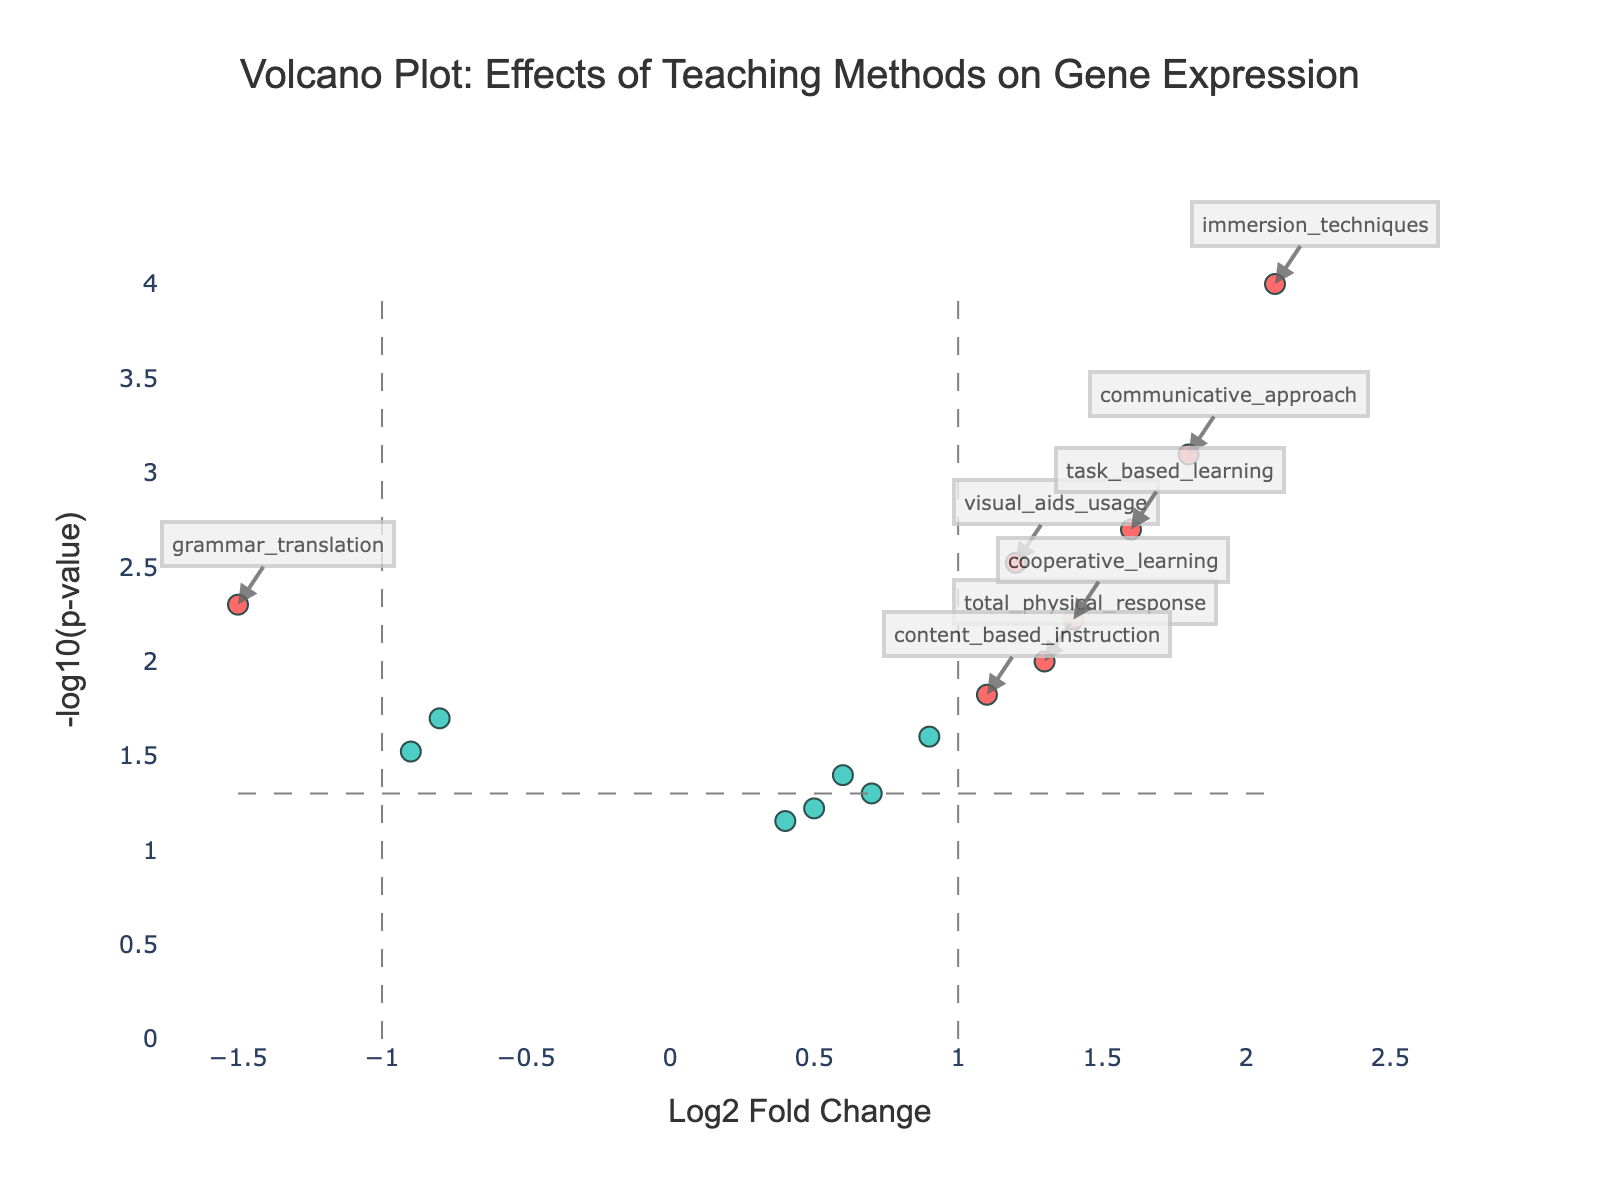What is the title of the plot? The title is usually located at the top of the plot and provides an overview of what the data represents. In this case, it reads "Volcano Plot: Effects of Teaching Methods on Gene Expression."
Answer: Volcano Plot: Effects of Teaching Methods on Gene Expression What are the axes labels on the plot? The x-axis and y-axis labels are crucial for understanding what the plot measures. The x-axis is labeled "Log2 Fold Change" and the y-axis is labeled "-log10(p-value)."
Answer: Log2 Fold Change and -log10(p-value) How many data points represent significant changes in gene expression? Significant changes are represented by points that are usually colored differently and labeled "Significant" in the legend. In this plot, there are 8 red points indicating significant changes.
Answer: 8 What teaching method corresponds to the highest -log10(p-value)? Find the data point with the highest y-axis value, which indicates the lowest p-value, and check the hover text or annotation to identify the corresponding teaching method. Here, the highest point corresponds to "immersion_techniques."
Answer: immersion_techniques Which teaching method has the highest Log2 Fold Change? The highest Log2 Fold Change corresponds to the data point farthest to the right on the x-axis. This point represents "immersion_techniques" with a Log2 Fold Change of 2.1.
Answer: immersion_techniques How does "grammar_translation" compare to "visual_aids_usage" in terms of Log2 Fold Change and p-value? Locate both points on the plot and compare their positions. "grammar_translation" has a Log2 Fold Change of -1.5 and a p-value smaller than 0.005, whereas "visual_aids_usage" has a Log2 Fold Change of 1.2 and a p-value of 0.003, making "visual_aids_usage" more significant in the positive direction and "grammar_translation" more significant in the negative direction.
Answer: grammar_translation has a lower Log2 Fold Change and both have low p-values What is the p-value threshold indicated by the dashed horizontal line? The dashed horizontal line represents a p-value significance threshold, typically located at -log10(0.05). Calculate -log10(0.05), which is approximately 1.3.
Answer: 1.3 Which teaching methods are not considered significant based on the plot's thresholds? Points that are colored differently and lie within the thresholds on the plot (gray points) represent non-significant methods. These include "suggestopedia," "natural_approach," and "direct_method."
Answer: suggestopedia, natural_approach, direct_method 